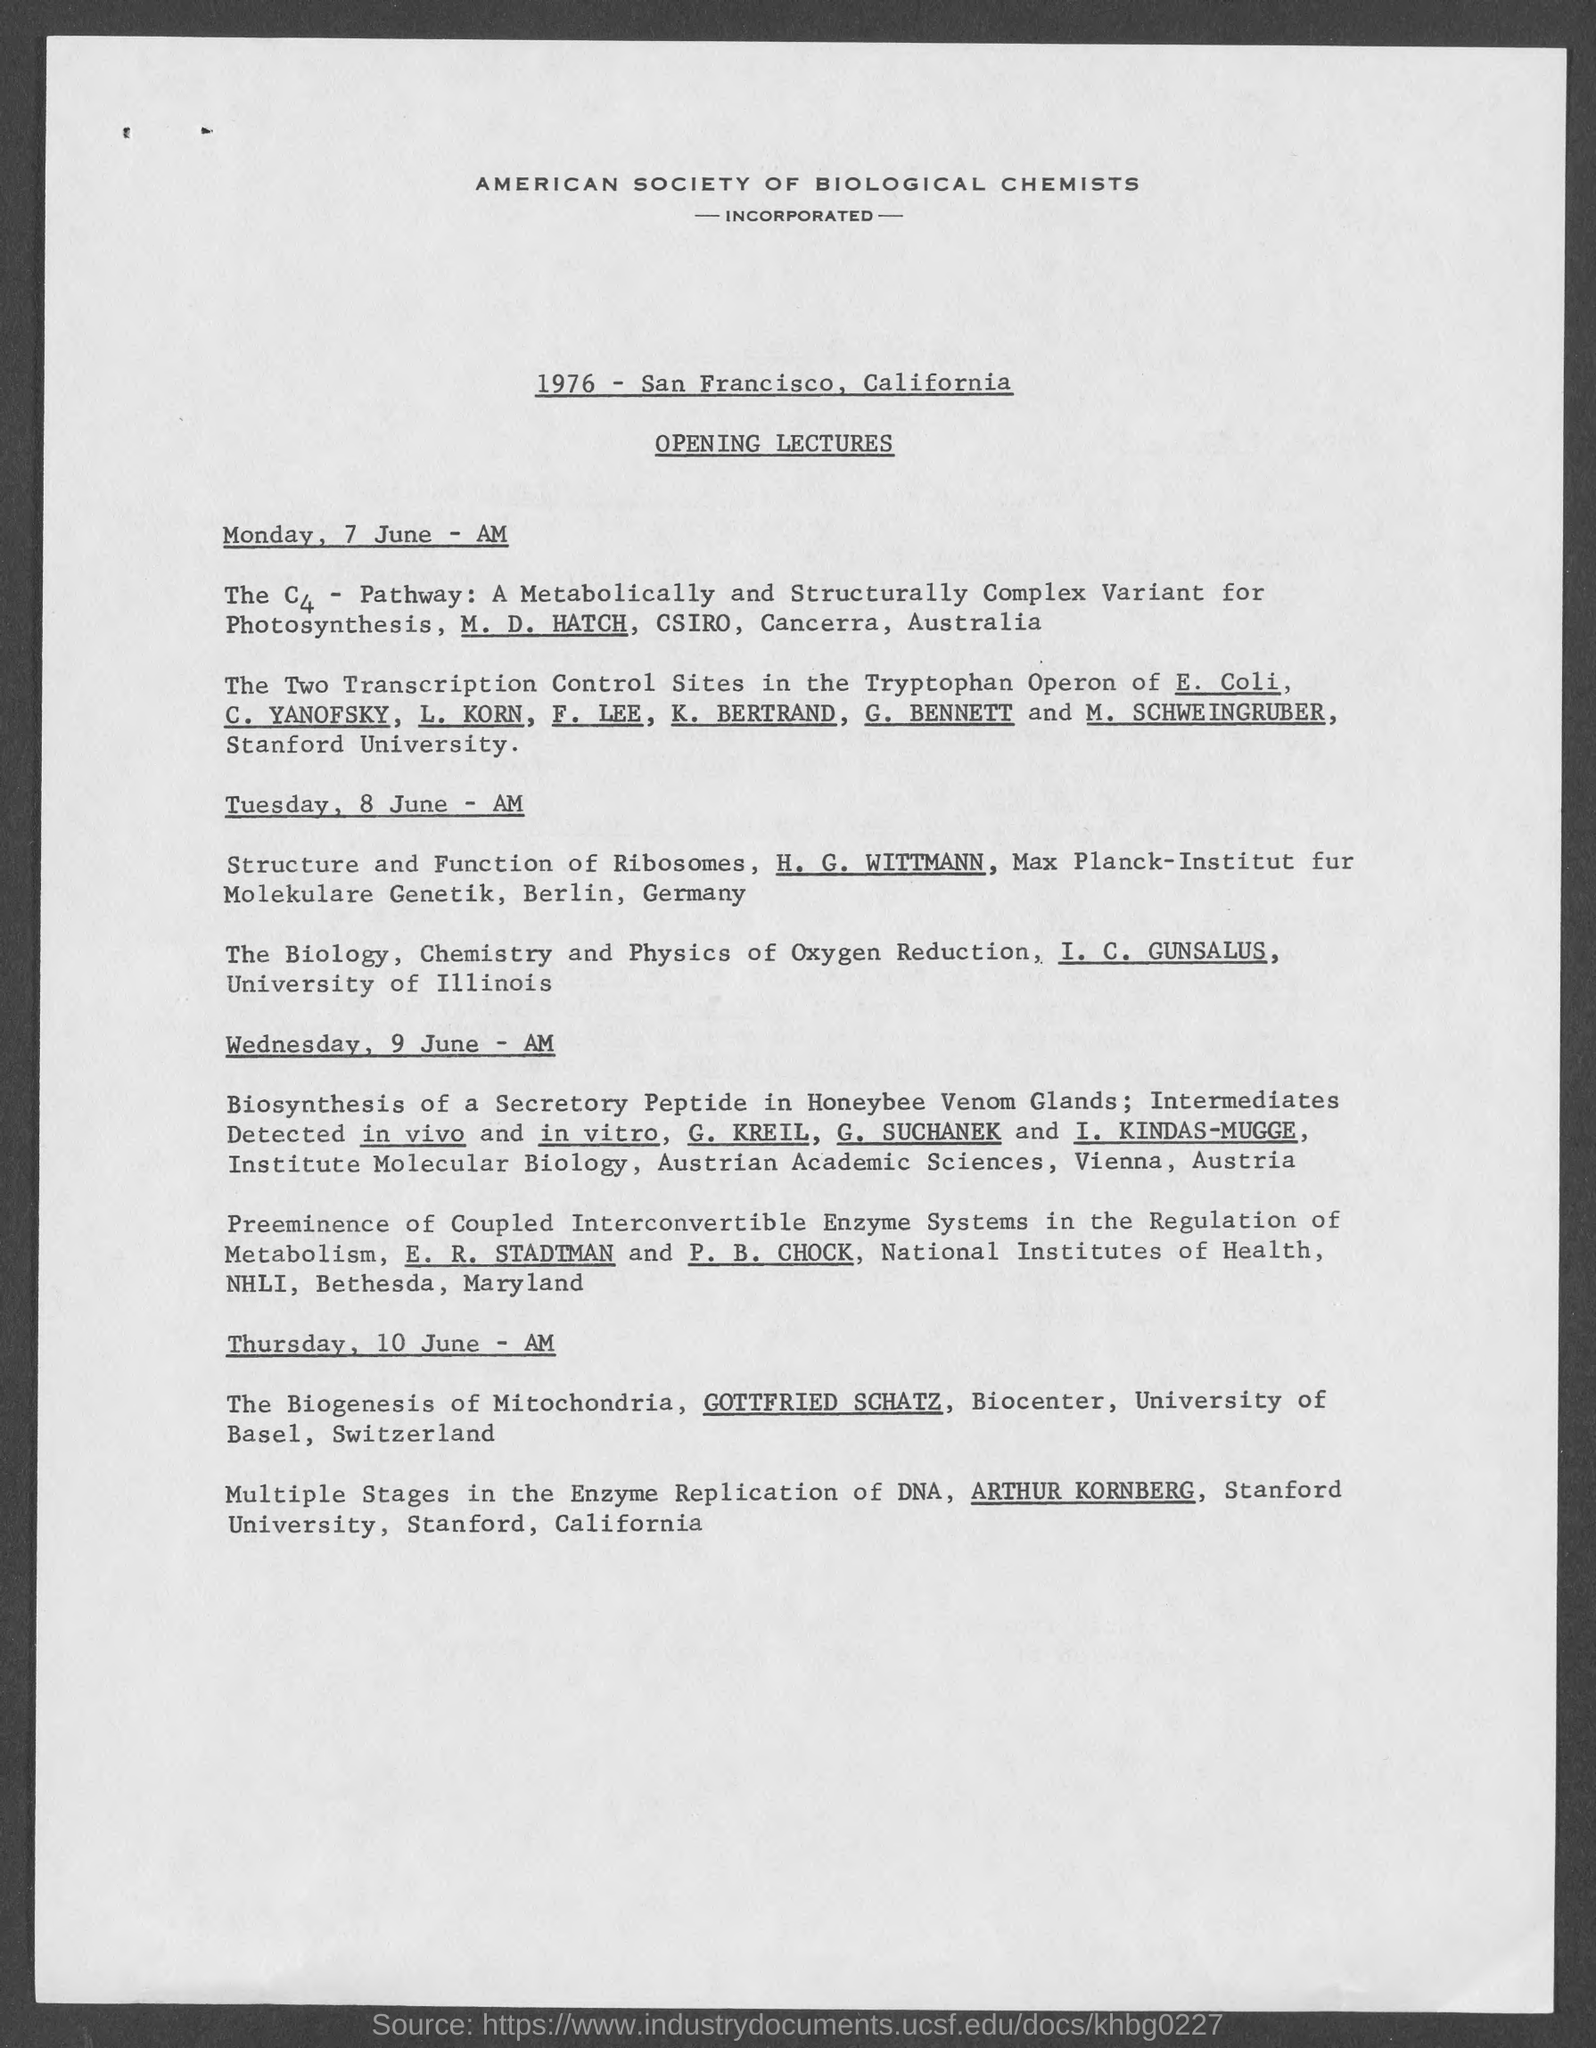Outline some significant characteristics in this image. I. C. Gunsalus is from the University of Illinois. The speaker delivering a lecture on the biology, chemistry, and physics of oxygen reduction is I.C. Gunsalus. The University of Basel is located in Switzerland. The lecture on the C4 pathway will take place on Monday, June 7th in the morning. 